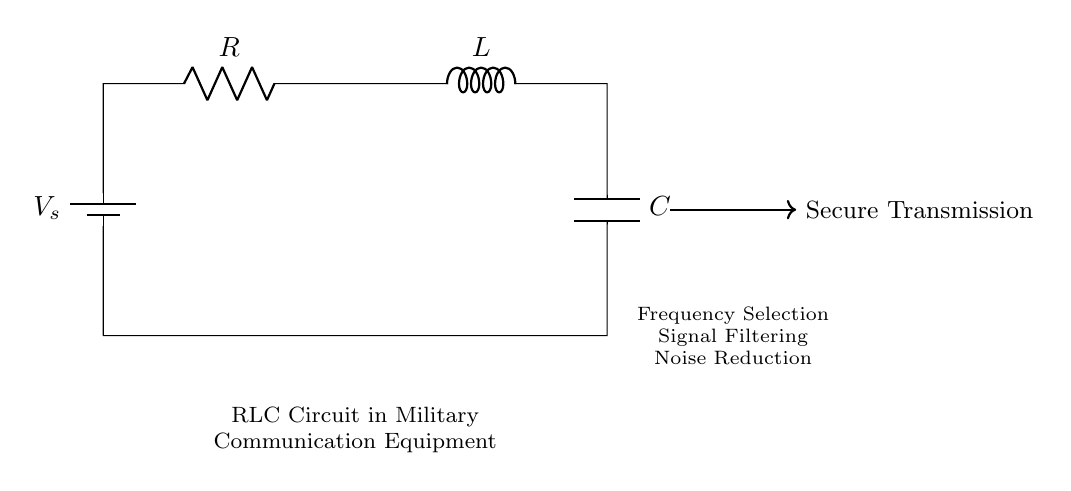What are the components of this circuit? The circuit includes a battery, resistor, inductor, and capacitor, as shown in the diagram. These components are labeled directly next to them, allowing for easy identification.
Answer: battery, resistor, inductor, capacitor What is the purpose of the RLC circuit in military communication? The RLC circuit is employed for frequency selection, signal filtering, and noise reduction in military communication equipment, enhancing secure transmissions. This is indicated in the notes below the circuit diagram.
Answer: secure transmissions What is the role of the inductor in this circuit? The inductor stores energy in a magnetic field and allows a control of current flow, which contributes to frequency selection and filtering in the communication signals. This is a core function of inductors in RLC circuits.
Answer: energy storage What type of circuit is this? This circuit is categorized as an RLC circuit, specifically because it consists of a resistor, inductor, and capacitor connected in series, impacting the circuit's behavior through impedance and resonance.
Answer: RLC circuit What happens if the resistance is increased? Increasing the resistance in an RLC circuit typically leads to a decrease in the overall current, impacting damping and how quickly oscillations die out. Higher resistance results in greater energy loss as heat.
Answer: decreases current What is one function provided by the capacitor in this circuit? The capacitor serves to store and release electrical energy, aiding in signal filtering and smoothing in the communications process. This feature is crucial for avoiding distortion in received signals.
Answer: signal filtering 